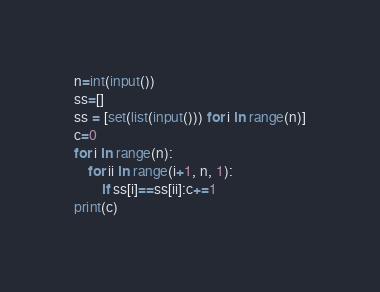<code> <loc_0><loc_0><loc_500><loc_500><_Python_>
n=int(input())
ss=[]
ss = [set(list(input())) for i in range(n)]
c=0
for i in range(n):
    for ii in range(i+1, n, 1):
        if ss[i]==ss[ii]:c+=1
print(c)</code> 